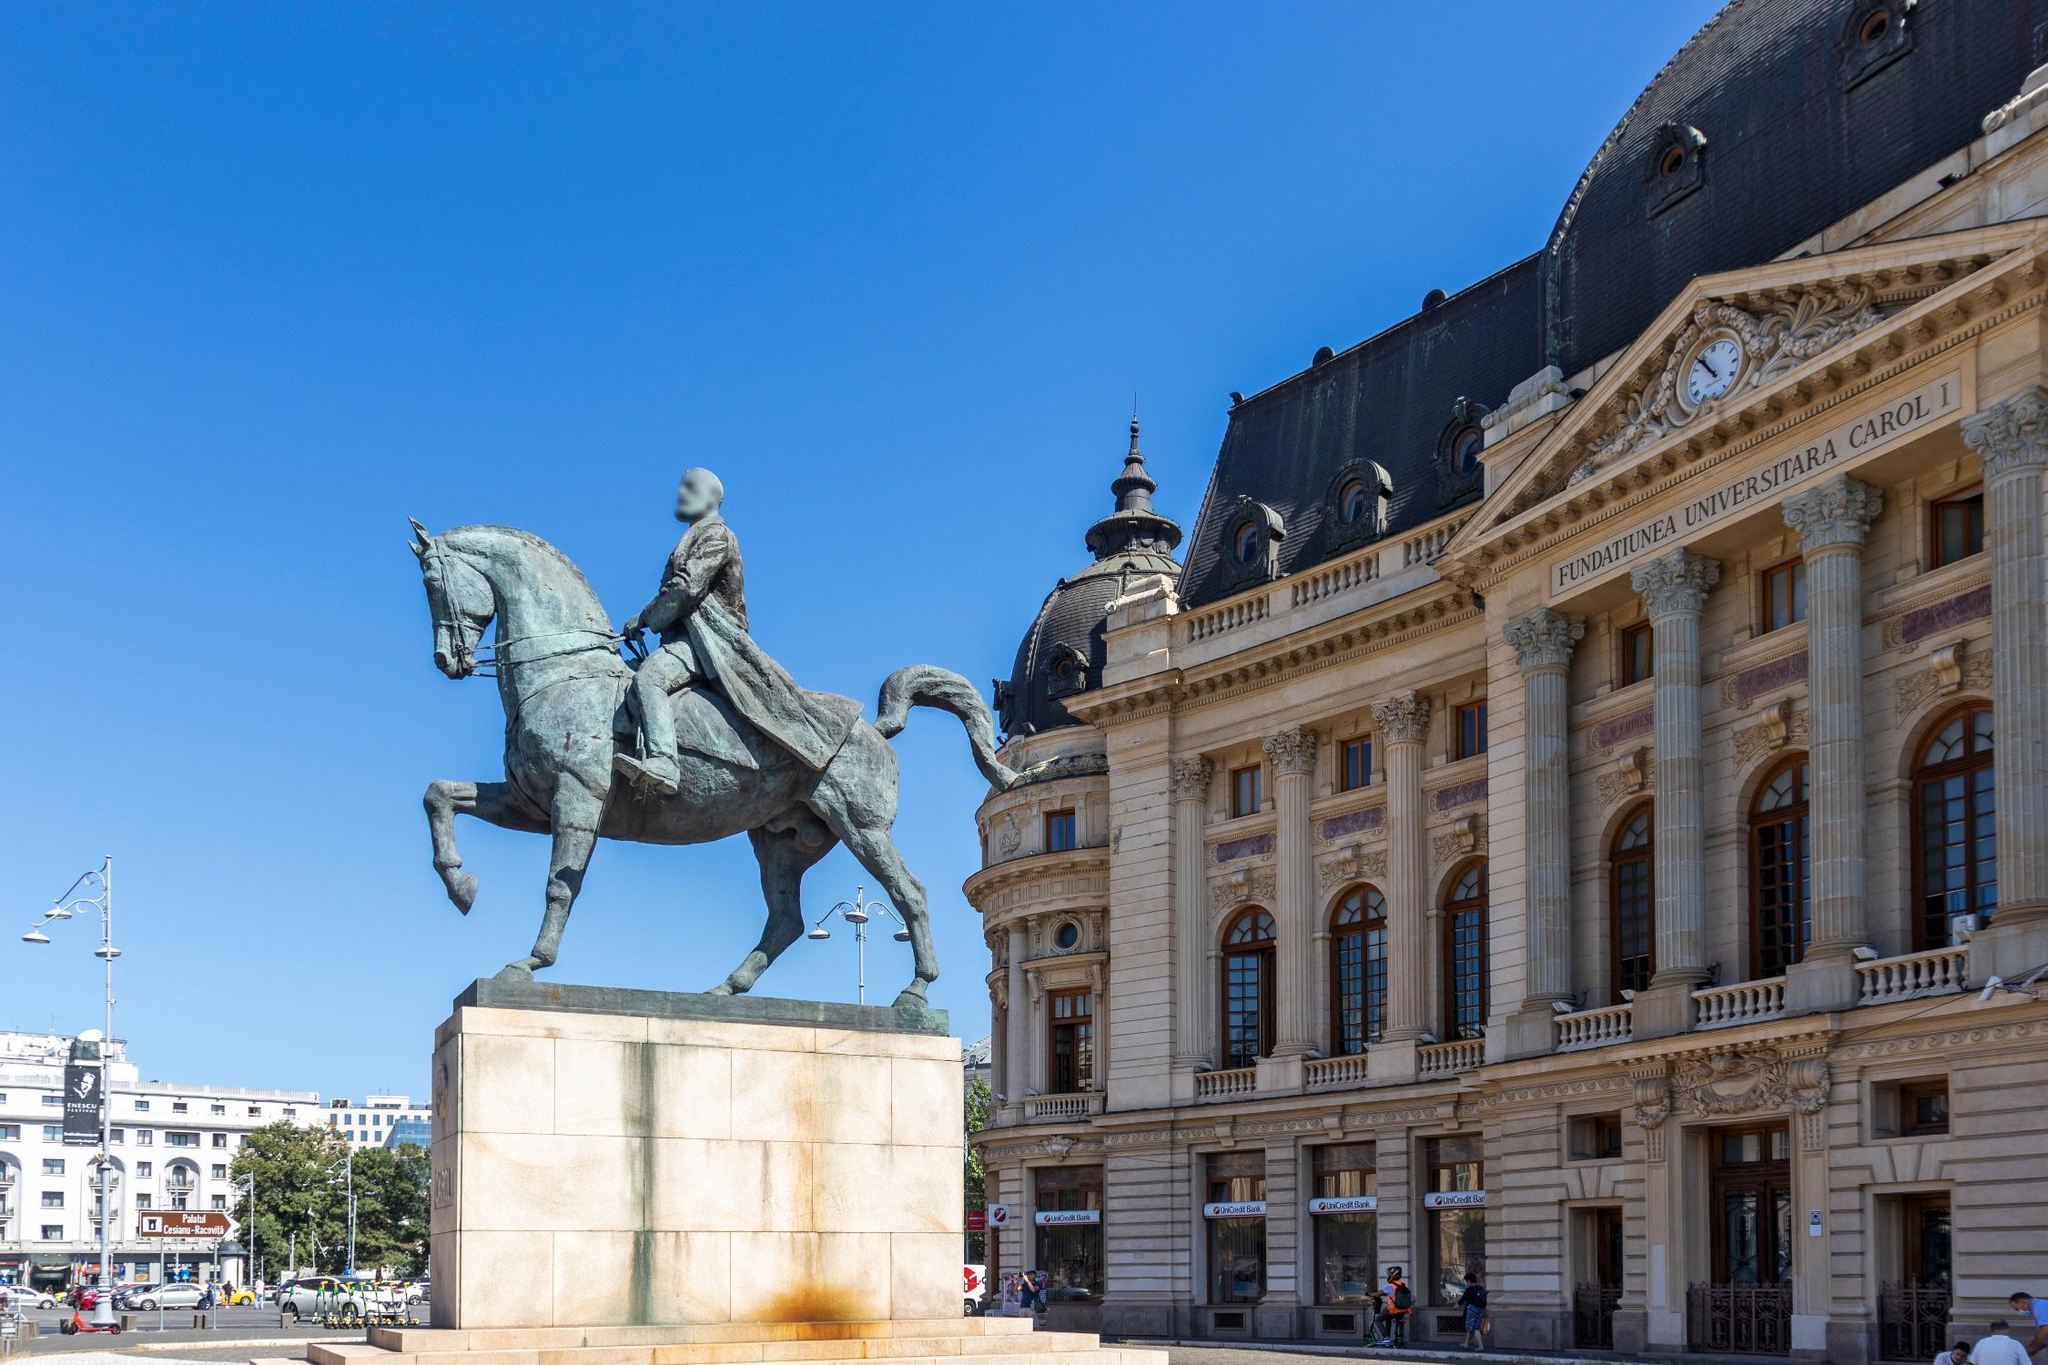What do you think the person in the statue was thinking? The person immortalized in the statue likely embodies a moment of triumph and determination. With a sword held high, his thoughts could have been focused on victory, leadership, and the resolve to lead his people through a pivotal moment in history. His expression of focus and authority indicates his readiness to face challenges head-on and emerge victorious for the greater good of his nation. If a visitor were to stand at the base of the statue, what might they feel or think? Standing at the base of the statue, a visitor would likely feel a sense of awe and inspiration. Gazing up at the powerful figure on horseback, they might reflect on the historical significance and the legacy of the person depicted. They could be filled with admiration for the courage and leadership embodied by the statue, and feel a connection to the past, imagining the pivotal moments that led to the creation of such a monument. The grand building in the background would further enhance their sense of wonder, as it emphasizes the importance of the location and the history it represents. Is there a special time or occasion when this place becomes particularly meaningful or symbolic? This place likely becomes particularly meaningful or symbolic during national celebrations, memorial events, or anniversaries of historical events associated with the figure depicted in the statue. Such occasions would draw crowds who come to pay their respects, celebrate their heritage, and reflect on the accomplishments and sacrifices of their forebears. The square might be adorned with flags, flowers, and other commemorative symbols, transforming it into a site of collective remembrance and pride. Ceremonies, parades, and public speeches could further elevate the significance of the location, strengthening the community's connection to its shared history. In a future where statues can communicate, what might this statue say to passersby? In a future where statues can communicate, this statue might say to passersby: 'Greetings, traveler. I am the guardian of this place, a sentinel of history. I was forged in a time of valor and leadership, striving for a brighter future. Learn from our past, cherish the freedom fought for, and embody the courage that defines our legacy. Stand tall, be courageous, and let the stories of our struggles and triumphs guide you forward. Remember, every step you take adds to the narrative of our nation. Honor it with pride and resilience.' 